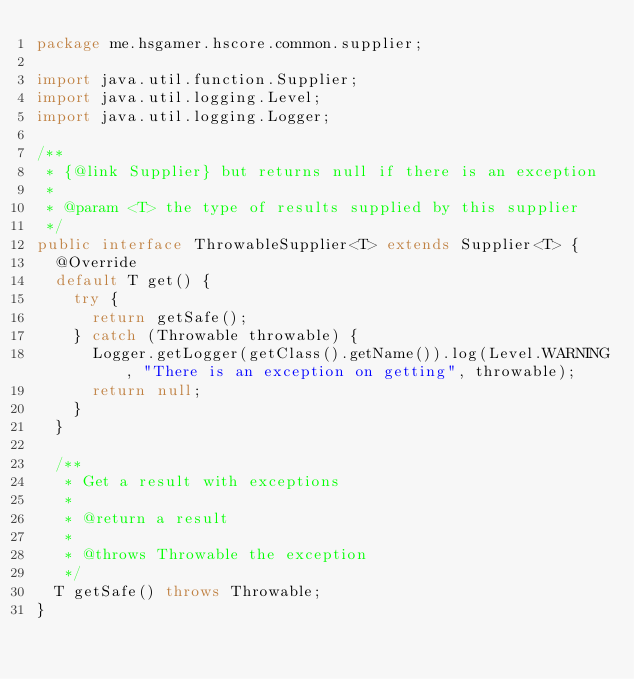<code> <loc_0><loc_0><loc_500><loc_500><_Java_>package me.hsgamer.hscore.common.supplier;

import java.util.function.Supplier;
import java.util.logging.Level;
import java.util.logging.Logger;

/**
 * {@link Supplier} but returns null if there is an exception
 *
 * @param <T> the type of results supplied by this supplier
 */
public interface ThrowableSupplier<T> extends Supplier<T> {
  @Override
  default T get() {
    try {
      return getSafe();
    } catch (Throwable throwable) {
      Logger.getLogger(getClass().getName()).log(Level.WARNING, "There is an exception on getting", throwable);
      return null;
    }
  }

  /**
   * Get a result with exceptions
   *
   * @return a result
   *
   * @throws Throwable the exception
   */
  T getSafe() throws Throwable;
}
</code> 